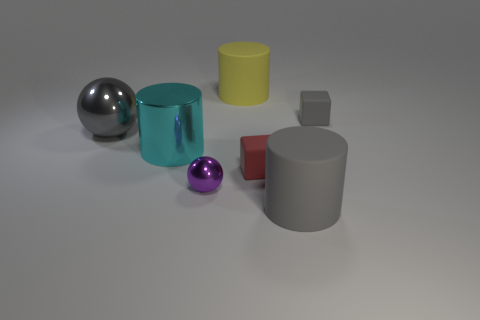Subtract all metal cylinders. How many cylinders are left? 2 Add 1 cyan matte blocks. How many objects exist? 8 Subtract all yellow cylinders. How many cylinders are left? 2 Subtract all cylinders. How many objects are left? 4 Subtract 3 cylinders. How many cylinders are left? 0 Subtract all brown cylinders. Subtract all brown spheres. How many cylinders are left? 3 Subtract all cyan cubes. How many cyan spheres are left? 0 Subtract all tiny gray metal things. Subtract all large gray objects. How many objects are left? 5 Add 3 big cyan metal objects. How many big cyan metal objects are left? 4 Add 4 big gray shiny spheres. How many big gray shiny spheres exist? 5 